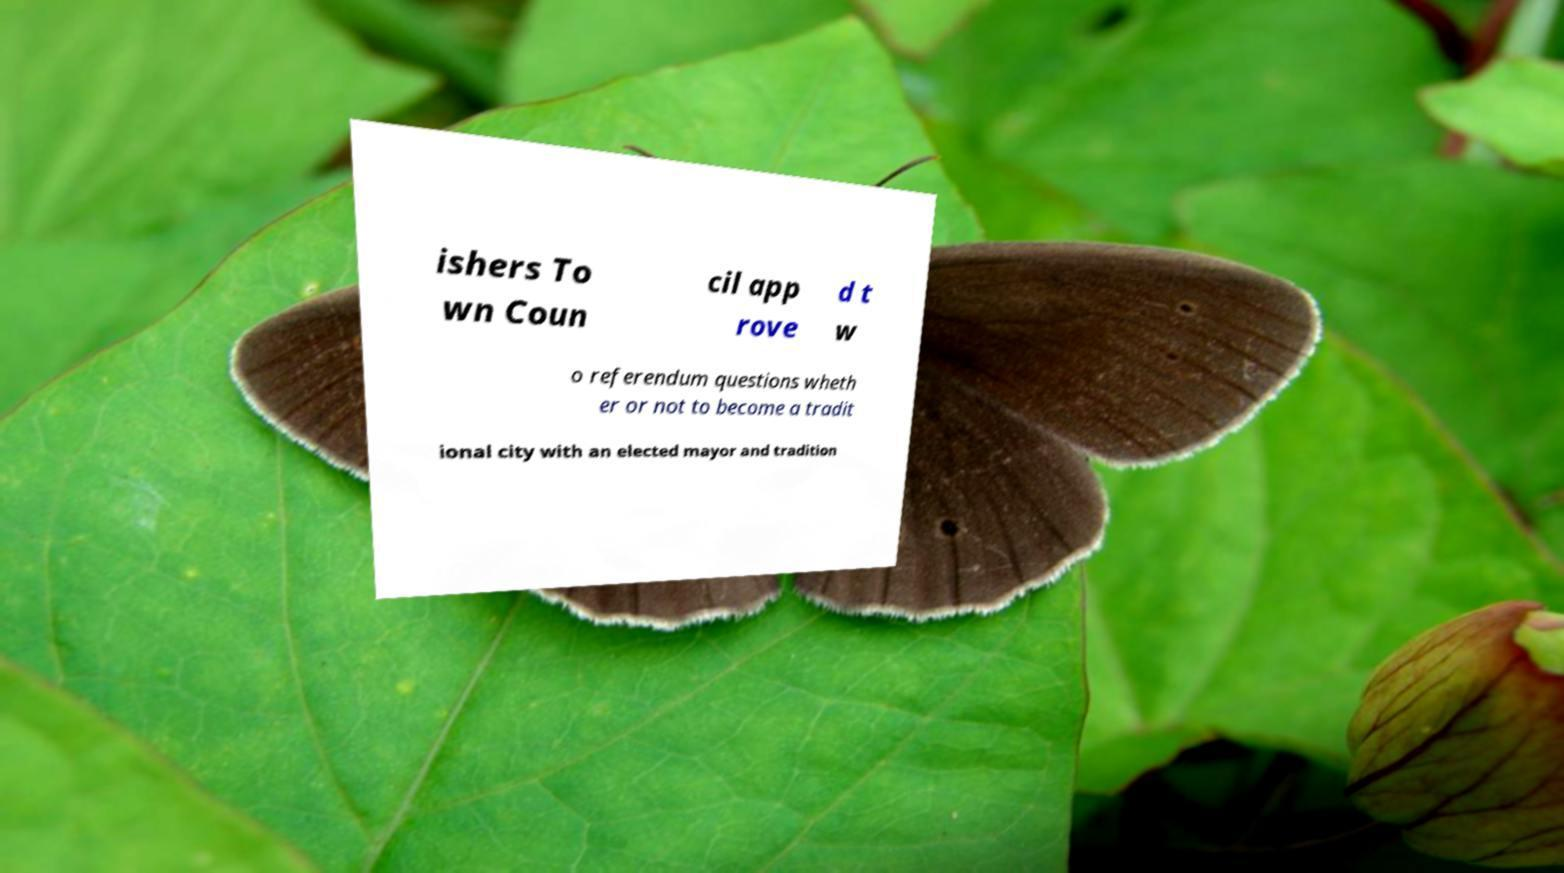Could you extract and type out the text from this image? ishers To wn Coun cil app rove d t w o referendum questions wheth er or not to become a tradit ional city with an elected mayor and tradition 